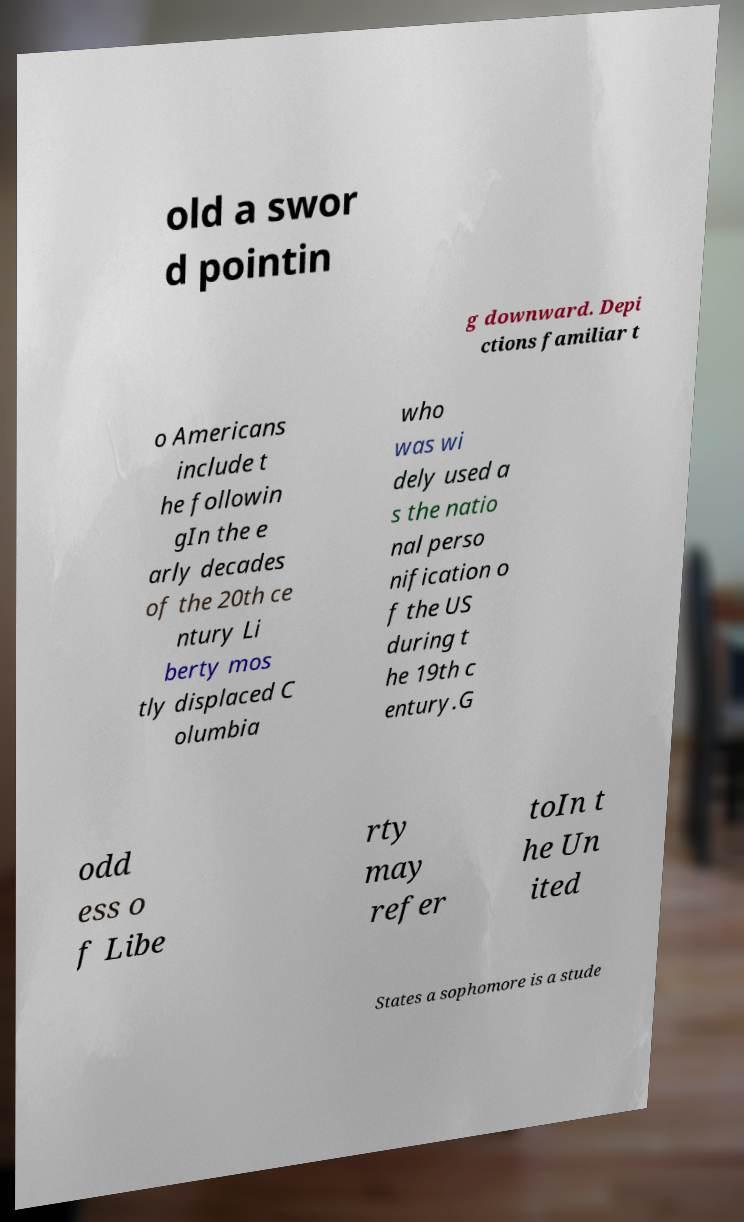Can you accurately transcribe the text from the provided image for me? old a swor d pointin g downward. Depi ctions familiar t o Americans include t he followin gIn the e arly decades of the 20th ce ntury Li berty mos tly displaced C olumbia who was wi dely used a s the natio nal perso nification o f the US during t he 19th c entury.G odd ess o f Libe rty may refer toIn t he Un ited States a sophomore is a stude 